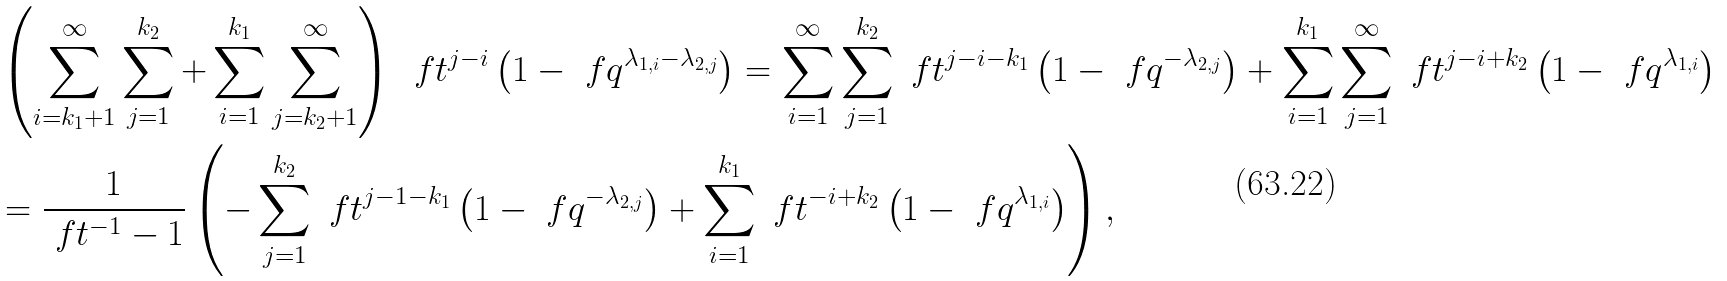<formula> <loc_0><loc_0><loc_500><loc_500>& \left ( \sum _ { i = k _ { 1 } + 1 } ^ { \infty } \sum _ { j = 1 } ^ { k _ { 2 } } + \sum _ { i = 1 } ^ { k _ { 1 } } \sum _ { j = k _ { 2 } + 1 } ^ { \infty } \right ) \, \ f t ^ { j - i } \left ( 1 - \ f q ^ { \lambda _ { 1 , i } - \lambda _ { 2 , j } } \right ) = \sum _ { i = 1 } ^ { \infty } \sum _ { j = 1 } ^ { k _ { 2 } } \ f t ^ { j - i - k _ { 1 } } \left ( 1 - \ f q ^ { - \lambda _ { 2 , j } } \right ) + \sum _ { i = 1 } ^ { k _ { 1 } } \sum _ { j = 1 } ^ { \infty } \ f t ^ { j - i + k _ { 2 } } \left ( 1 - \ f q ^ { \lambda _ { 1 , i } } \right ) \\ & = \frac { 1 } { \ f t ^ { - 1 } - 1 } \left ( - \sum _ { j = 1 } ^ { k _ { 2 } } \ f t ^ { j - 1 - k _ { 1 } } \left ( 1 - \ f q ^ { - \lambda _ { 2 , j } } \right ) + \sum _ { i = 1 } ^ { k _ { 1 } } \ f t ^ { - i + k _ { 2 } } \left ( 1 - \ f q ^ { \lambda _ { 1 , i } } \right ) \right ) ,</formula> 